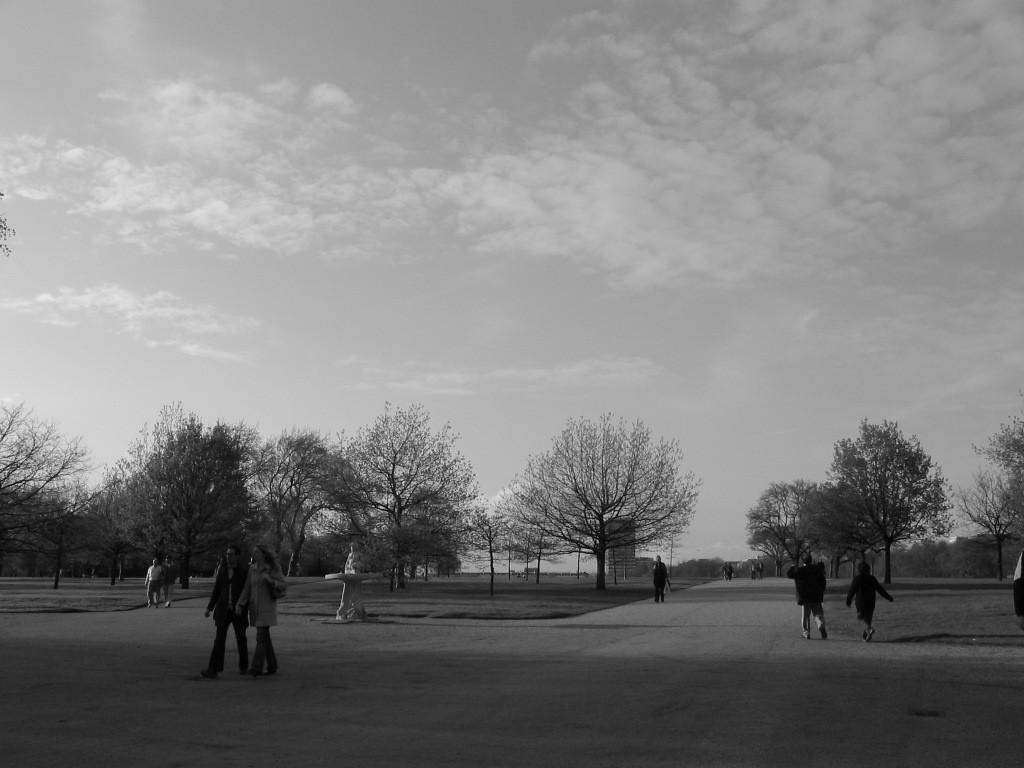Who or what can be seen in the image? There are people in the image. What are the people wearing? The people are wearing clothes. What are the people doing in the image? The people are walking. On what surface are the people walking? They are walking on a footpath. What type of natural environment is visible in the image? There are many trees in the image. What is the condition of the sky in the image? The sky is cloudy. How many towns can be seen in the image? There are no towns visible in the image; it features people walking on a footpath surrounded by trees. What type of grip does the mouth have in the image? There is no mouth present in the image, so it is not possible to determine its grip. 